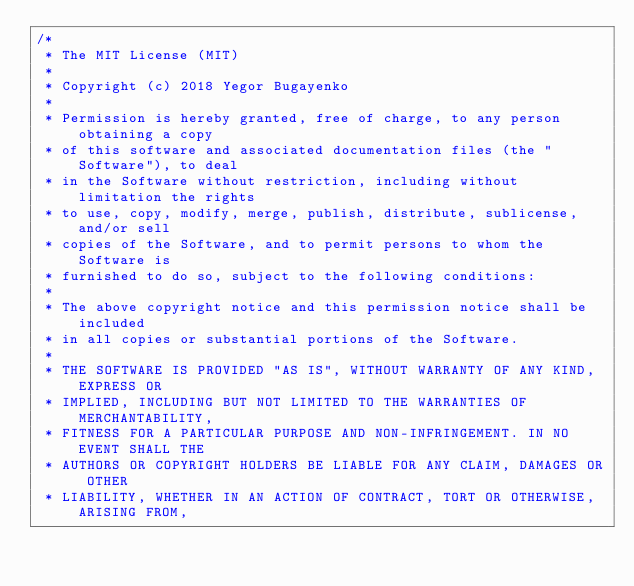Convert code to text. <code><loc_0><loc_0><loc_500><loc_500><_Java_>/*
 * The MIT License (MIT)
 *
 * Copyright (c) 2018 Yegor Bugayenko
 *
 * Permission is hereby granted, free of charge, to any person obtaining a copy
 * of this software and associated documentation files (the "Software"), to deal
 * in the Software without restriction, including without limitation the rights
 * to use, copy, modify, merge, publish, distribute, sublicense, and/or sell
 * copies of the Software, and to permit persons to whom the Software is
 * furnished to do so, subject to the following conditions:
 *
 * The above copyright notice and this permission notice shall be included
 * in all copies or substantial portions of the Software.
 *
 * THE SOFTWARE IS PROVIDED "AS IS", WITHOUT WARRANTY OF ANY KIND, EXPRESS OR
 * IMPLIED, INCLUDING BUT NOT LIMITED TO THE WARRANTIES OF MERCHANTABILITY,
 * FITNESS FOR A PARTICULAR PURPOSE AND NON-INFRINGEMENT. IN NO EVENT SHALL THE
 * AUTHORS OR COPYRIGHT HOLDERS BE LIABLE FOR ANY CLAIM, DAMAGES OR OTHER
 * LIABILITY, WHETHER IN AN ACTION OF CONTRACT, TORT OR OTHERWISE, ARISING FROM,</code> 